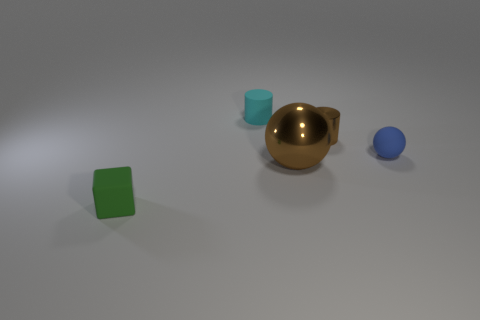Subtract 1 cylinders. How many cylinders are left? 1 Add 5 brown metal spheres. How many objects exist? 10 Subtract all blocks. How many objects are left? 4 Add 3 brown shiny spheres. How many brown shiny spheres exist? 4 Subtract 0 green cylinders. How many objects are left? 5 Subtract all purple blocks. Subtract all red cylinders. How many blocks are left? 1 Subtract all brown spheres. How many brown cylinders are left? 1 Subtract all big green objects. Subtract all tiny things. How many objects are left? 1 Add 5 large metallic spheres. How many large metallic spheres are left? 6 